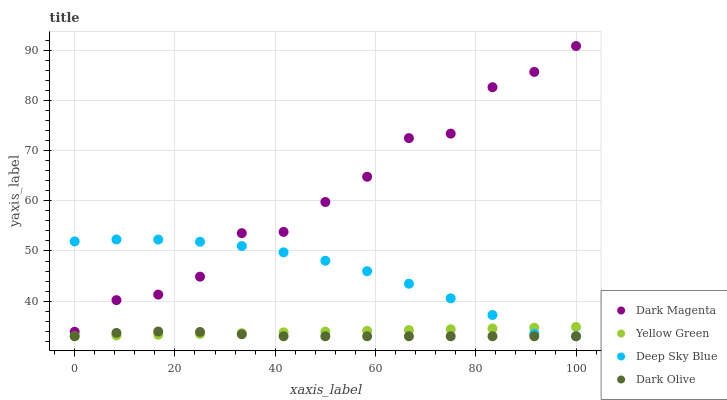Does Dark Olive have the minimum area under the curve?
Answer yes or no. Yes. Does Dark Magenta have the maximum area under the curve?
Answer yes or no. Yes. Does Deep Sky Blue have the minimum area under the curve?
Answer yes or no. No. Does Deep Sky Blue have the maximum area under the curve?
Answer yes or no. No. Is Yellow Green the smoothest?
Answer yes or no. Yes. Is Dark Magenta the roughest?
Answer yes or no. Yes. Is Deep Sky Blue the smoothest?
Answer yes or no. No. Is Deep Sky Blue the roughest?
Answer yes or no. No. Does Dark Olive have the lowest value?
Answer yes or no. Yes. Does Dark Magenta have the lowest value?
Answer yes or no. No. Does Dark Magenta have the highest value?
Answer yes or no. Yes. Does Deep Sky Blue have the highest value?
Answer yes or no. No. Is Yellow Green less than Dark Magenta?
Answer yes or no. Yes. Is Dark Magenta greater than Dark Olive?
Answer yes or no. Yes. Does Yellow Green intersect Deep Sky Blue?
Answer yes or no. Yes. Is Yellow Green less than Deep Sky Blue?
Answer yes or no. No. Is Yellow Green greater than Deep Sky Blue?
Answer yes or no. No. Does Yellow Green intersect Dark Magenta?
Answer yes or no. No. 